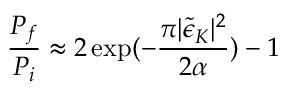Convert formula to latex. <formula><loc_0><loc_0><loc_500><loc_500>\frac { P _ { f } } { P _ { i } } \approx 2 \exp ( - \frac { \pi | \tilde { \epsilon } _ { K } | ^ { 2 } } { 2 \alpha } ) - 1</formula> 